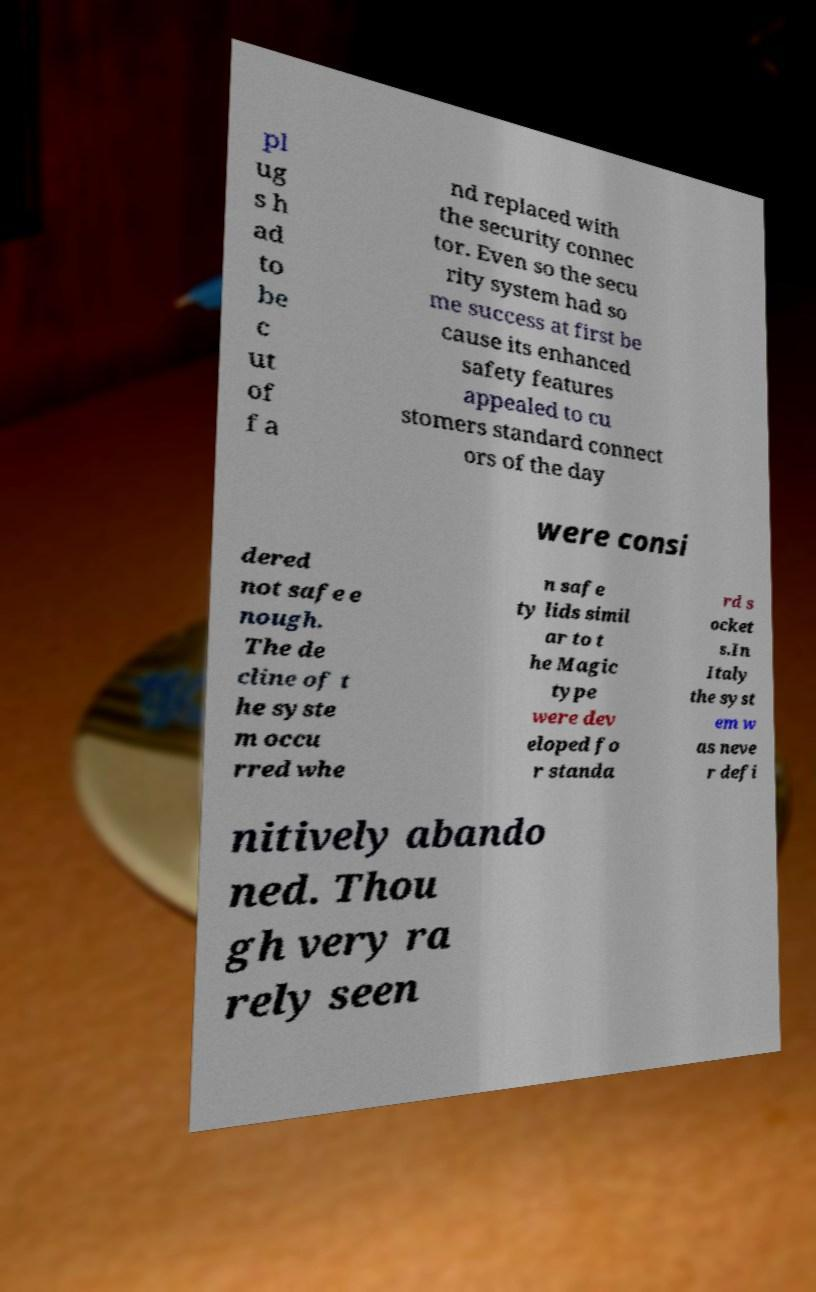Can you accurately transcribe the text from the provided image for me? pl ug s h ad to be c ut of f a nd replaced with the security connec tor. Even so the secu rity system had so me success at first be cause its enhanced safety features appealed to cu stomers standard connect ors of the day were consi dered not safe e nough. The de cline of t he syste m occu rred whe n safe ty lids simil ar to t he Magic type were dev eloped fo r standa rd s ocket s.In Italy the syst em w as neve r defi nitively abando ned. Thou gh very ra rely seen 